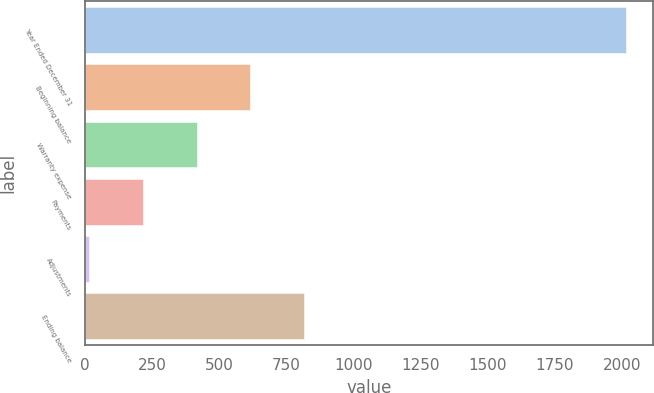Convert chart to OTSL. <chart><loc_0><loc_0><loc_500><loc_500><bar_chart><fcel>Year Ended December 31<fcel>Beginning balance<fcel>Warranty expense<fcel>Payments<fcel>Adjustments<fcel>Ending balance<nl><fcel>2016<fcel>615.3<fcel>415.2<fcel>215.1<fcel>15<fcel>815.4<nl></chart> 